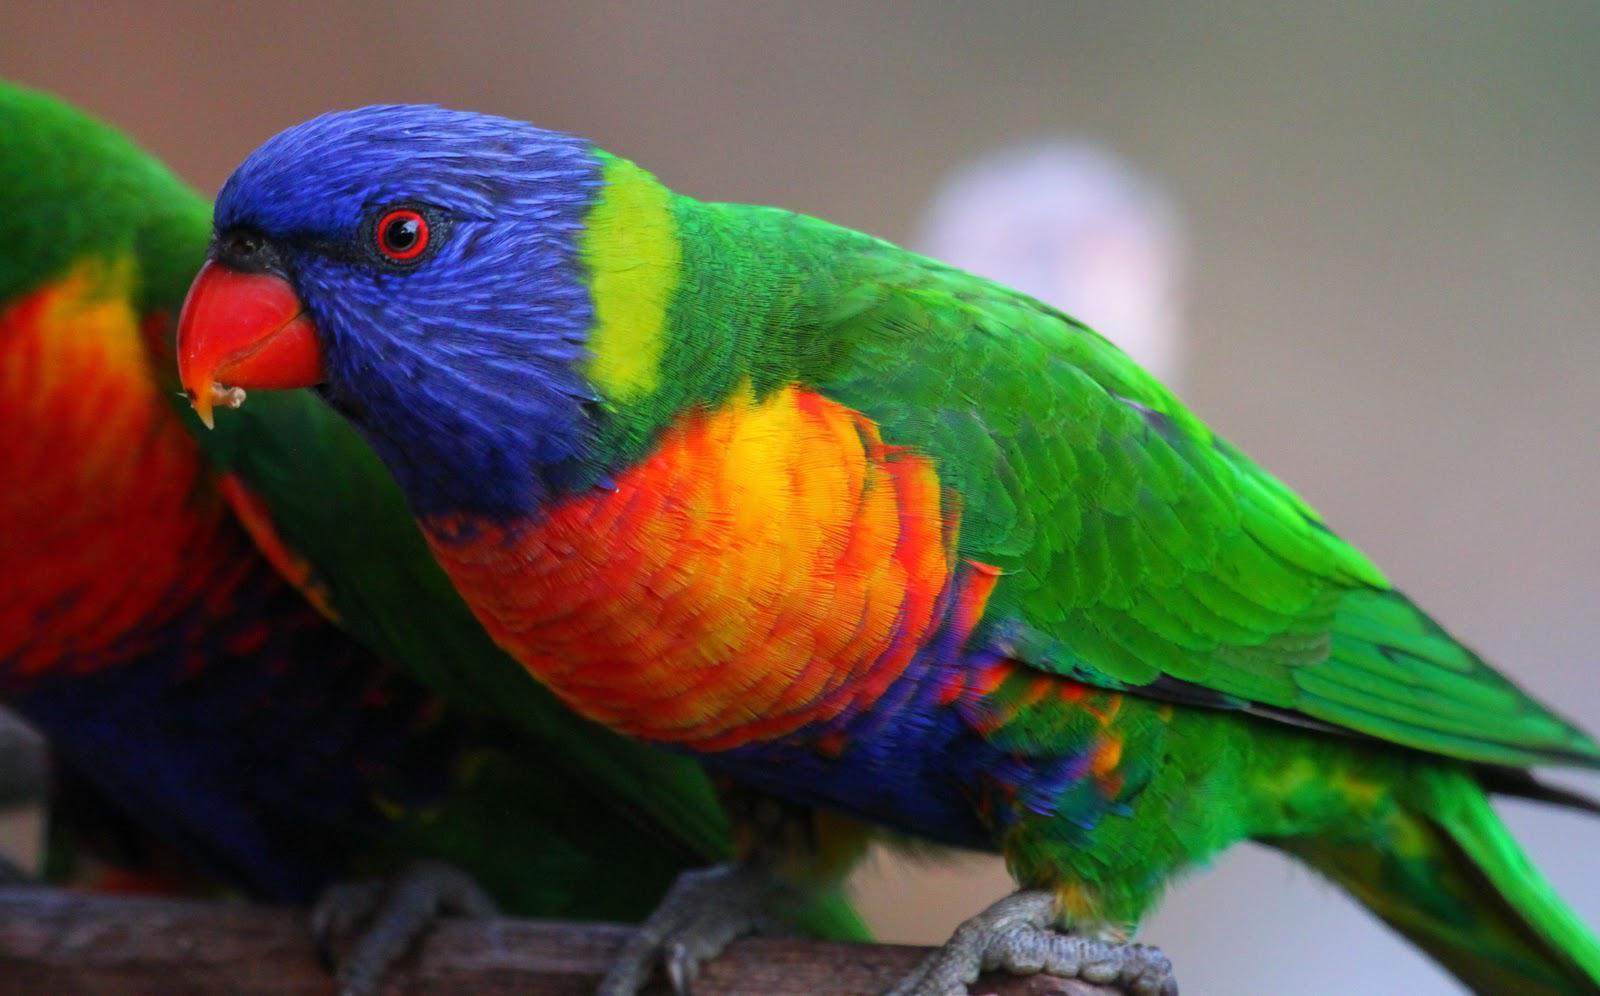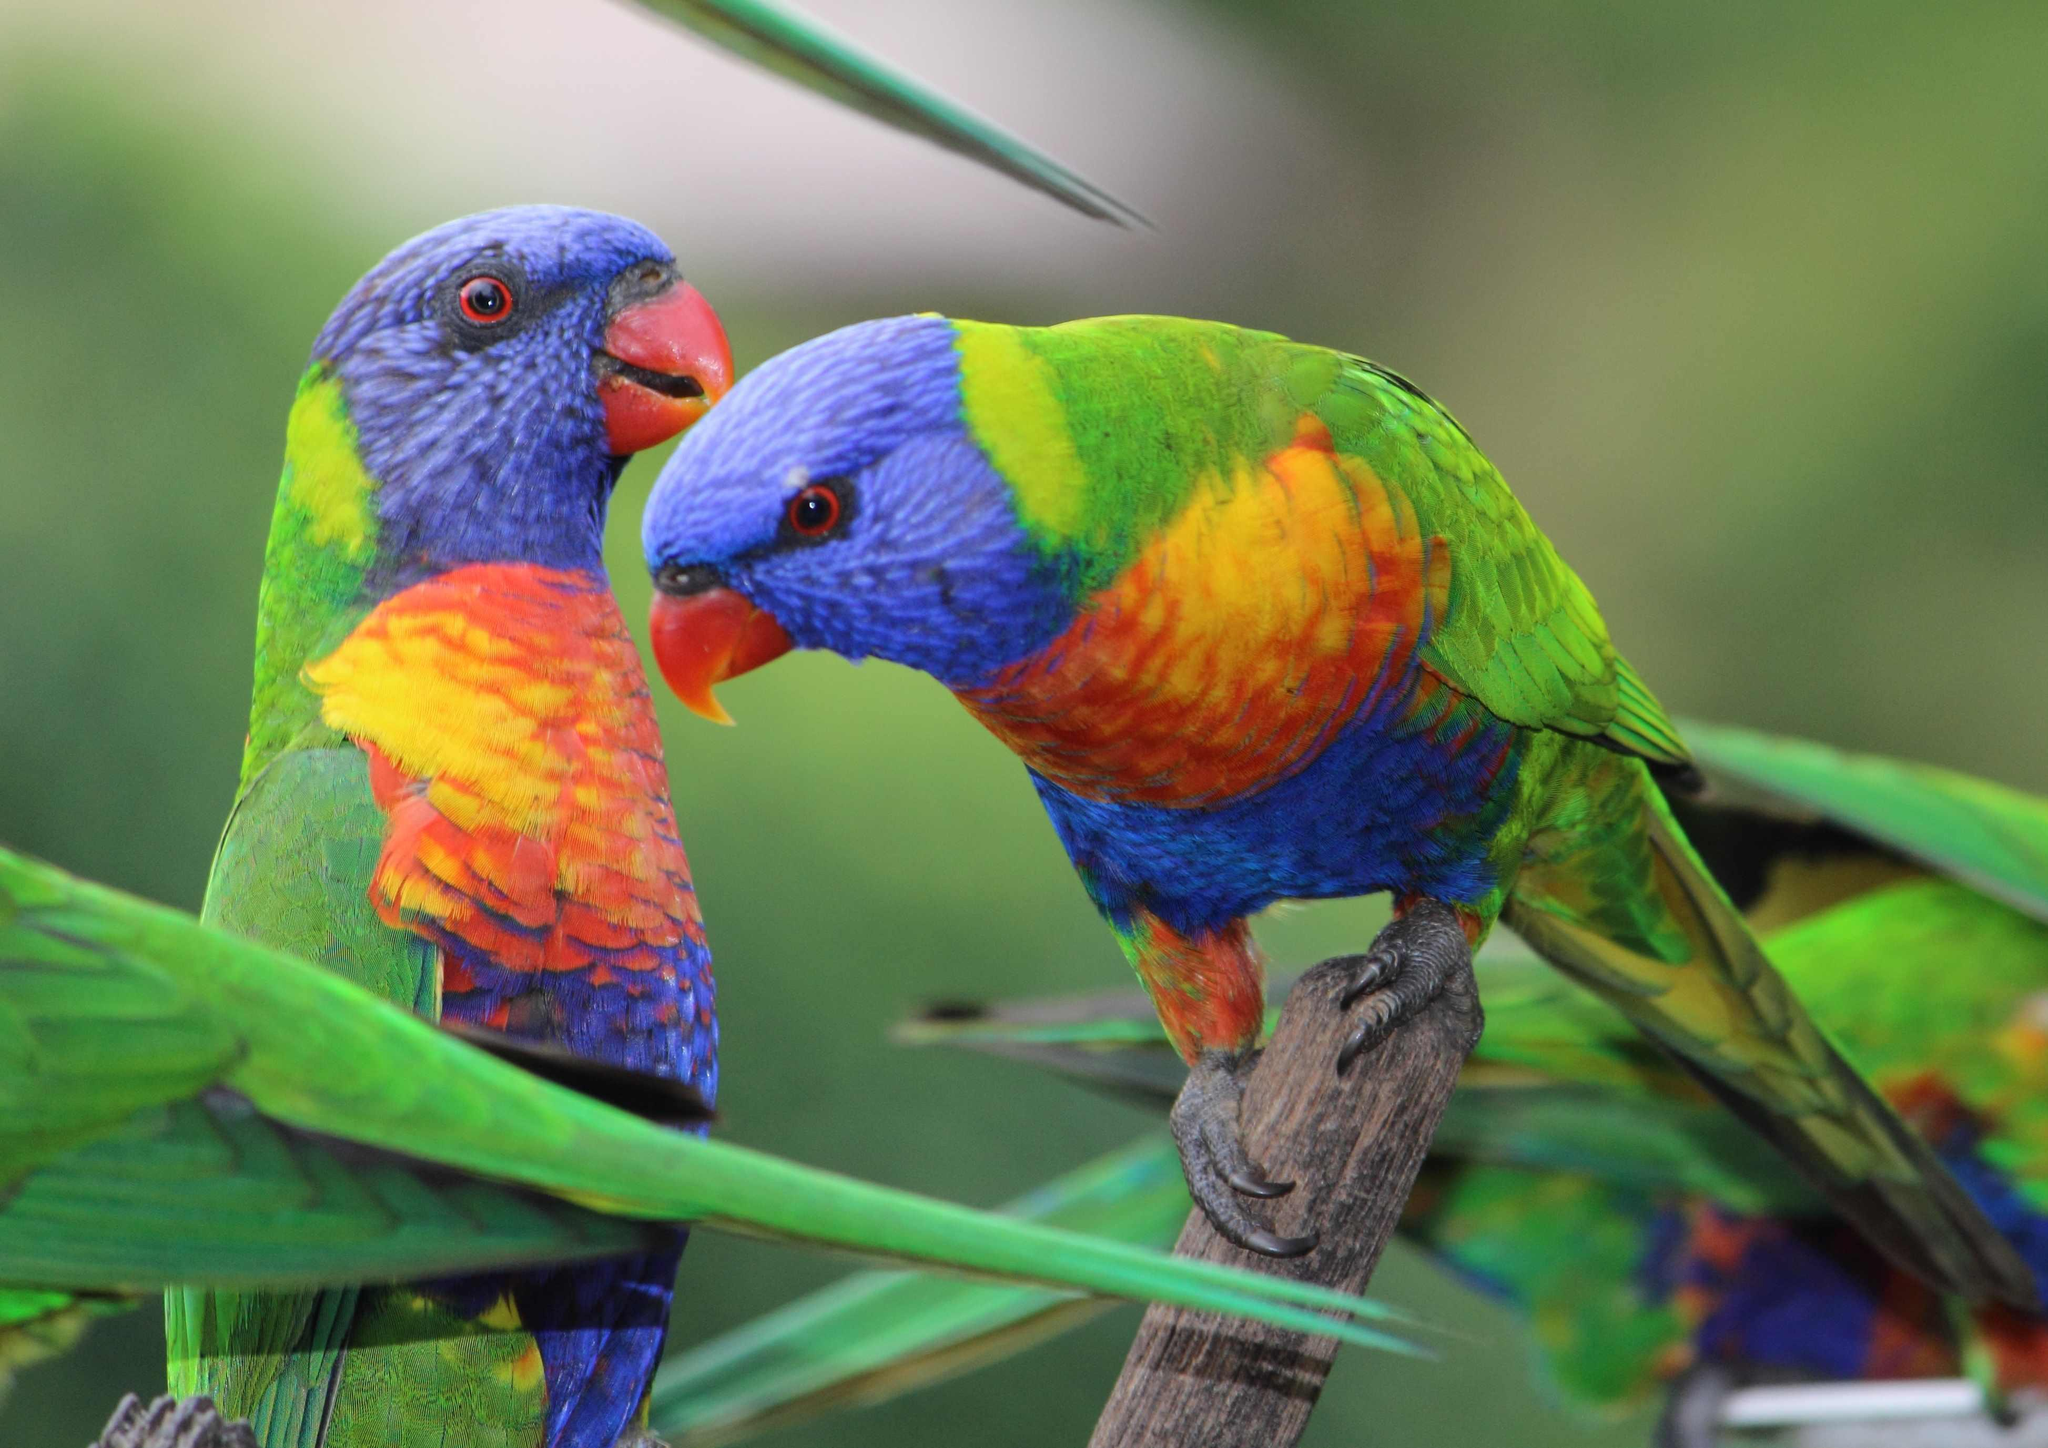The first image is the image on the left, the second image is the image on the right. Assess this claim about the two images: "At least two parrots are facing left.". Correct or not? Answer yes or no. Yes. The first image is the image on the left, the second image is the image on the right. Analyze the images presented: Is the assertion "The left image includes twice as many parrots as the right image." valid? Answer yes or no. No. 